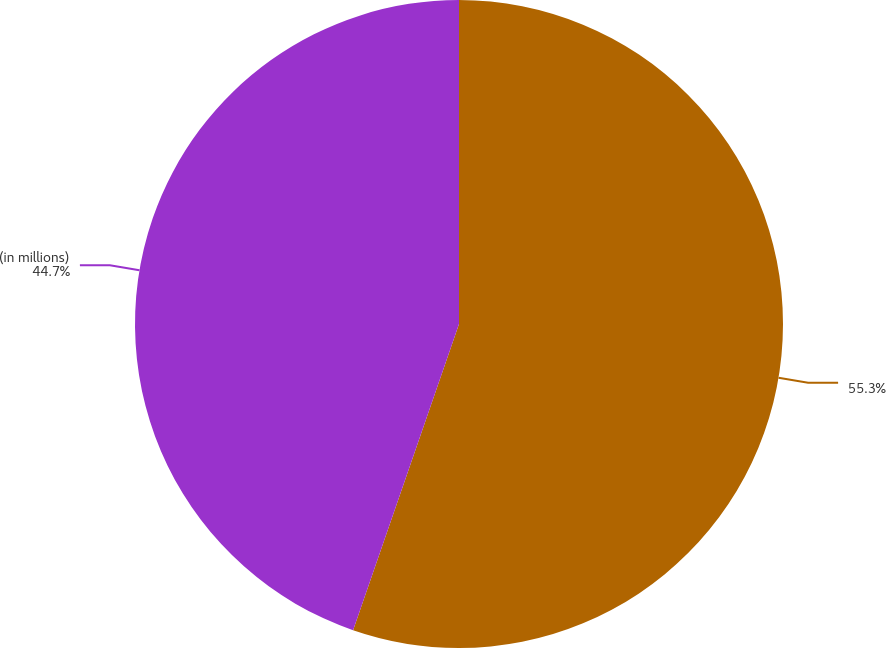<chart> <loc_0><loc_0><loc_500><loc_500><pie_chart><ecel><fcel>(in millions)<nl><fcel>55.3%<fcel>44.7%<nl></chart> 